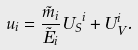Convert formula to latex. <formula><loc_0><loc_0><loc_500><loc_500>u _ { i } = \frac { \tilde { m } _ { i } } { \tilde { E } _ { i } } { U _ { S } } ^ { i } + U _ { V } ^ { i } .</formula> 